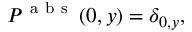Convert formula to latex. <formula><loc_0><loc_0><loc_500><loc_500>P ^ { a b s } \left ( 0 , y \right ) = \delta _ { 0 , y } ,</formula> 